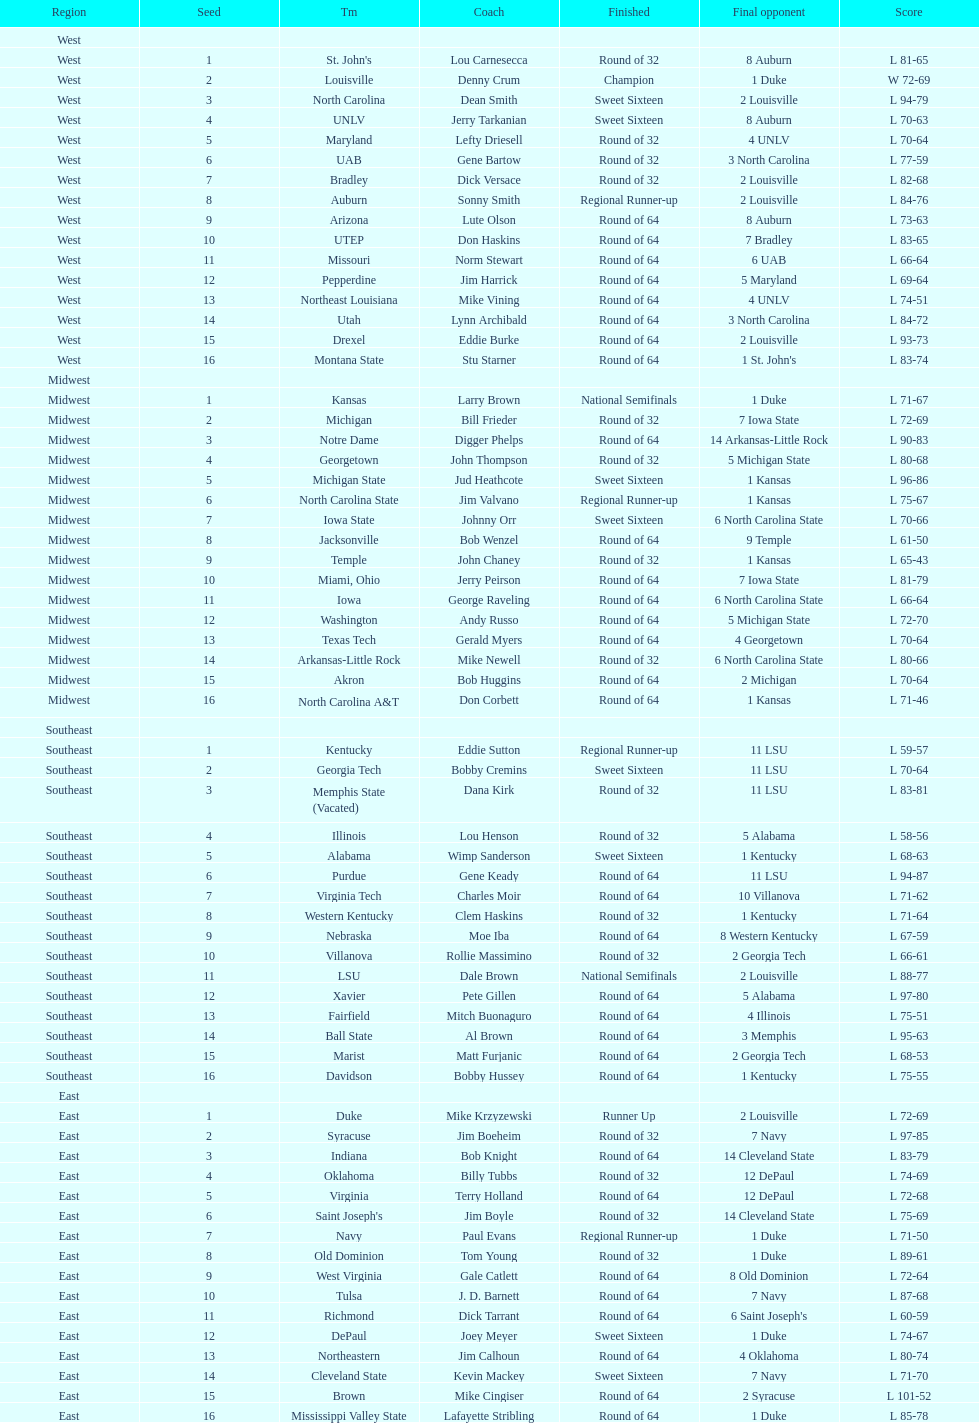Which team went finished later in the tournament, st. john's or north carolina a&t? North Carolina A&T. 